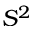<formula> <loc_0><loc_0><loc_500><loc_500>S ^ { 2 }</formula> 